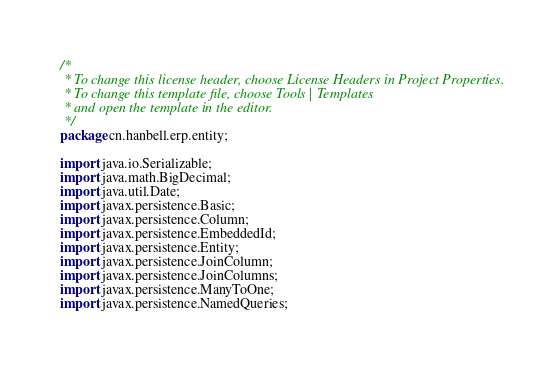<code> <loc_0><loc_0><loc_500><loc_500><_Java_>/*
 * To change this license header, choose License Headers in Project Properties.
 * To change this template file, choose Tools | Templates
 * and open the template in the editor.
 */
package cn.hanbell.erp.entity;

import java.io.Serializable;
import java.math.BigDecimal;
import java.util.Date;
import javax.persistence.Basic;
import javax.persistence.Column;
import javax.persistence.EmbeddedId;
import javax.persistence.Entity;
import javax.persistence.JoinColumn;
import javax.persistence.JoinColumns;
import javax.persistence.ManyToOne;
import javax.persistence.NamedQueries;</code> 